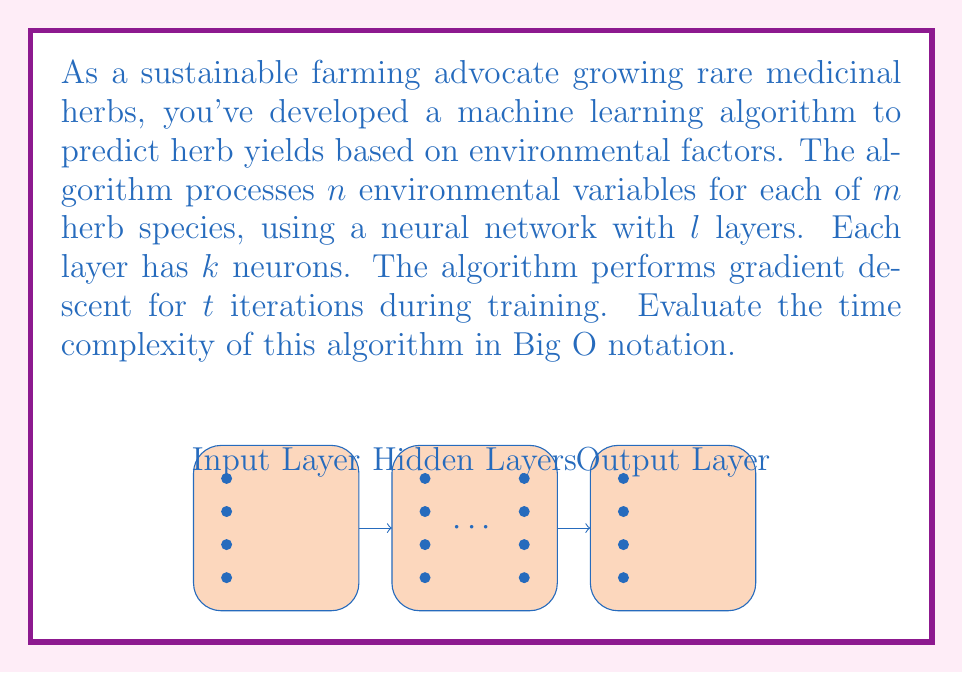Can you answer this question? To evaluate the time complexity, we need to consider the main operations in the algorithm:

1) Input processing: 
   - Time complexity: $O(n \cdot m)$, as we process $n$ variables for each of $m$ species.

2) Forward propagation through the neural network:
   - For each layer: $O(k^2)$ operations (matrix multiplication)
   - Total layers: $l$
   - Time complexity for one forward pass: $O(l \cdot k^2)$

3) Backpropagation and weight updates:
   - Similar to forward propagation: $O(l \cdot k^2)$

4) Iterations of gradient descent:
   - The forward and backward passes are repeated $t$ times
   - Time complexity: $O(t \cdot l \cdot k^2)$

5) This process is done for each of the $m$ herb species:
   - Total time complexity: $O(m \cdot t \cdot l \cdot k^2)$

6) Including the input processing:
   - Final time complexity: $O(n \cdot m + m \cdot t \cdot l \cdot k^2)$

7) Simplifying, assuming $n < t \cdot l \cdot k^2$ (which is typically the case for complex neural networks):
   - The dominant term is $m \cdot t \cdot l \cdot k^2$

Therefore, the overall time complexity of the algorithm is $O(m \cdot t \cdot l \cdot k^2)$.
Answer: $O(m \cdot t \cdot l \cdot k^2)$ 